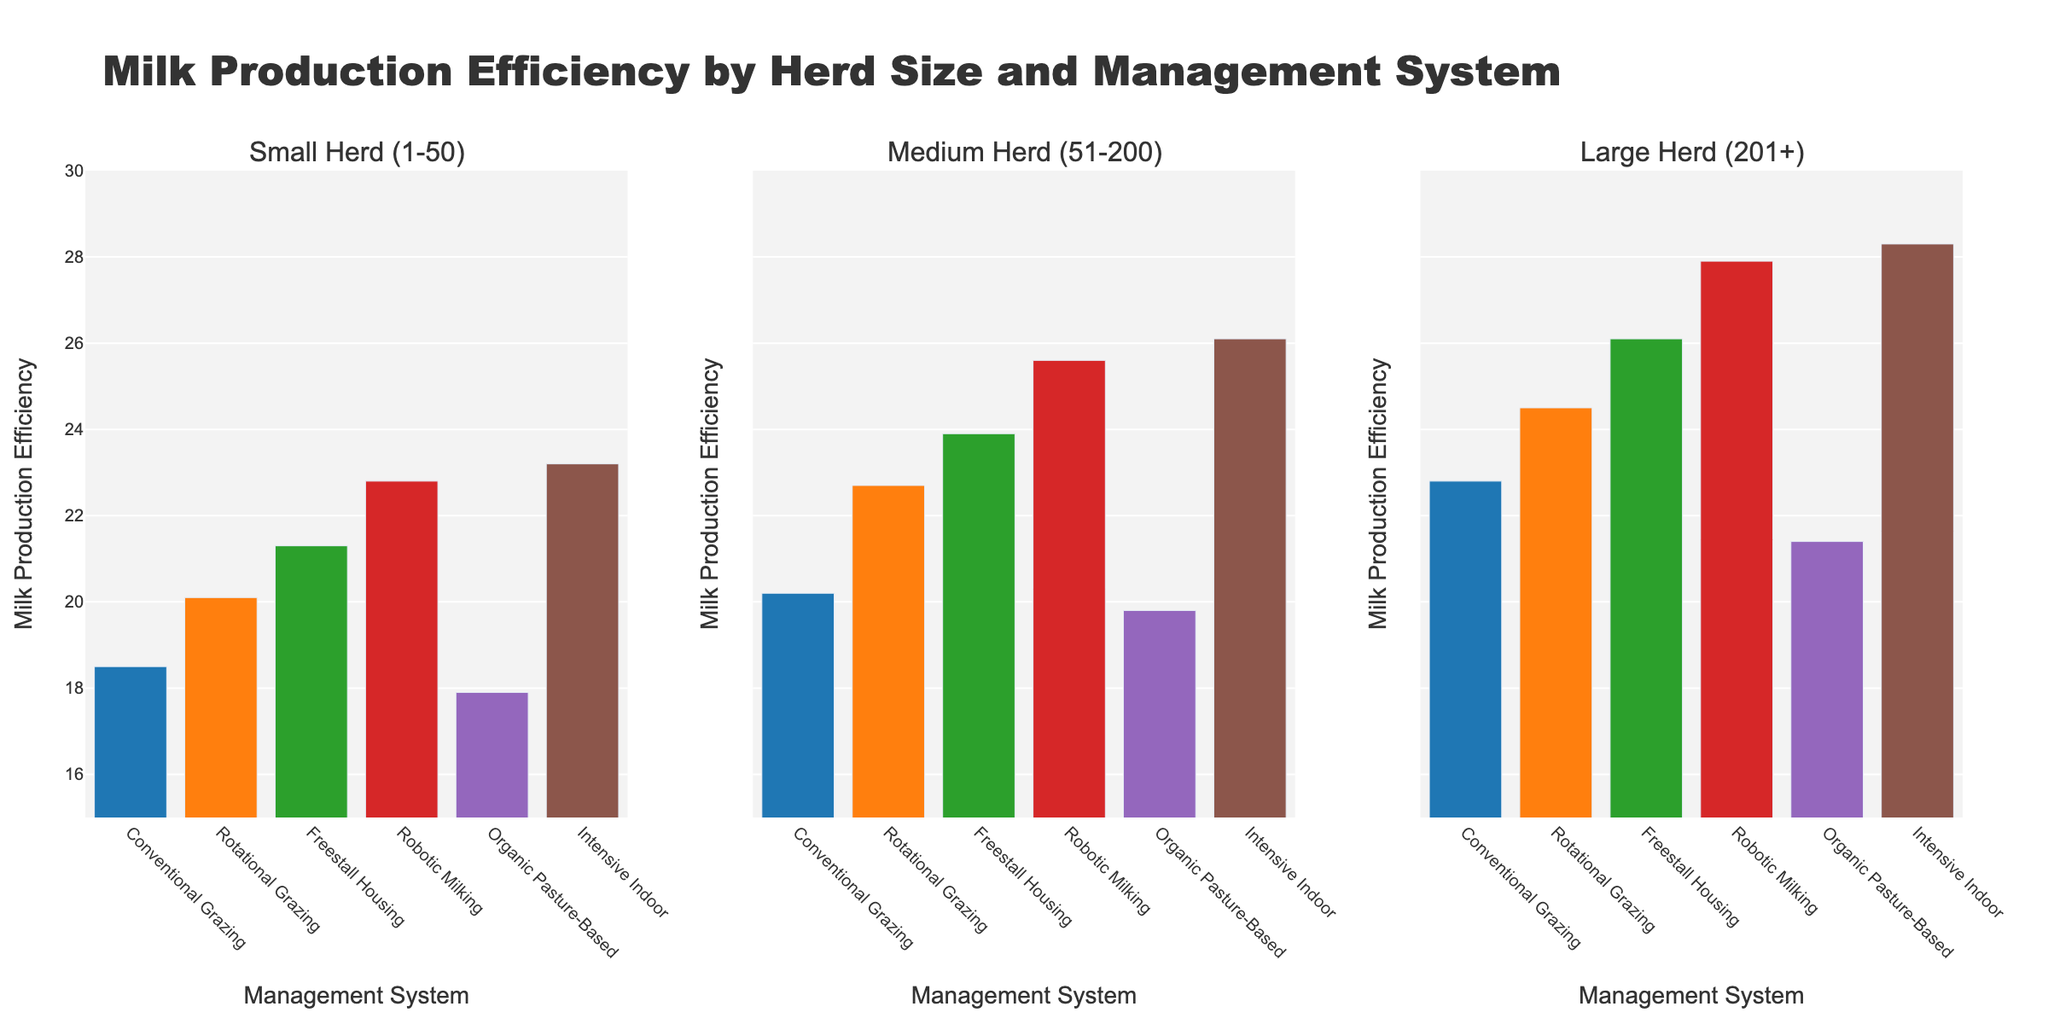Which management system shows the highest milk production efficiency for small herds (1-50)? For small herds (1-50), look for the highest bar in the corresponding subplot. The highest bar corresponds to the "Intensive Indoor" system at around 23.2.
Answer: Intensive Indoor How does the milk production efficiency of Rotational Grazing compare between medium herds (51-200) and large herds (201+)? Compare the height of the Rotational Grazing bars in the second and third subplots. The medium herd value is 22.7 and the large herd value is 24.5.
Answer: Efficiency for large herds is higher What is the average milk production efficiency for Freestall Housing across all herd sizes? Add the values for Freestall Housing from all subplots (21.3 + 23.9 + 26.1) and then divide by 3.
Answer: 23.77 Which management system has the smallest difference in milk production efficiency between small herds (1-50) and large herds (201+)? Calculate the differences for each system between the small and large herd values, then identify the smallest difference. For Conventional Grazing: 22.8 - 18.5 = 4.3, Rotational Grazing: 24.5 - 20.1 = 4.4, Freestall Housing: 26.1 - 21.3 = 4.8, Robotic Milking: 27.9 - 22.8 = 5.1, Organic Pasture-Based: 21.4 - 17.9 = 3.5, Intensive Indoor: 28.3 - 23.2 = 5.1. The smallest difference is 3.5 for Organic Pasture-Based.
Answer: Organic Pasture-Based What is the total milk production efficiency of Conventional Grazing and Organic Pasture-Based for medium herds (51-200)? Add the values for Conventional Grazing (20.2) and Organic Pasture-Based (19.8) in the second subplot.
Answer: 40.0 How does the milk production efficiency of Robotic Milking for small herds (1-50) compare to Organic Pasture-Based for large herds (201+)? Compare the height of the Robotic Milking bar in the first subplot (22.8) with the height of the Organic Pasture-Based bar in the third subplot (21.4).
Answer: Robotic Milking is higher Which herd size shows the highest average milk production efficiency across all management systems? Calculate the averages for each herd size: Small Herd: (18.5 + 20.1 + 21.3 + 22.8 + 17.9 + 23.2) / 6, Medium Herd: (20.2 + 22.7 + 23.9 + 25.6 + 19.8 + 26.1) / 6, Large Herd: (22.8 + 24.5 + 26.1 + 27.9 + 21.4 + 28.3) / 6. Small: 20.63, Medium: 23.05, Large: 25.17. The highest average is for Large Herds.
Answer: Large Herds Which management system shows the lowest milk production efficiency for any herd size? Identify the lowest bar across all subplots. The lowest bar is for Organic Pasture-Based in the first subplot at 17.9.
Answer: Organic Pasture-Based 